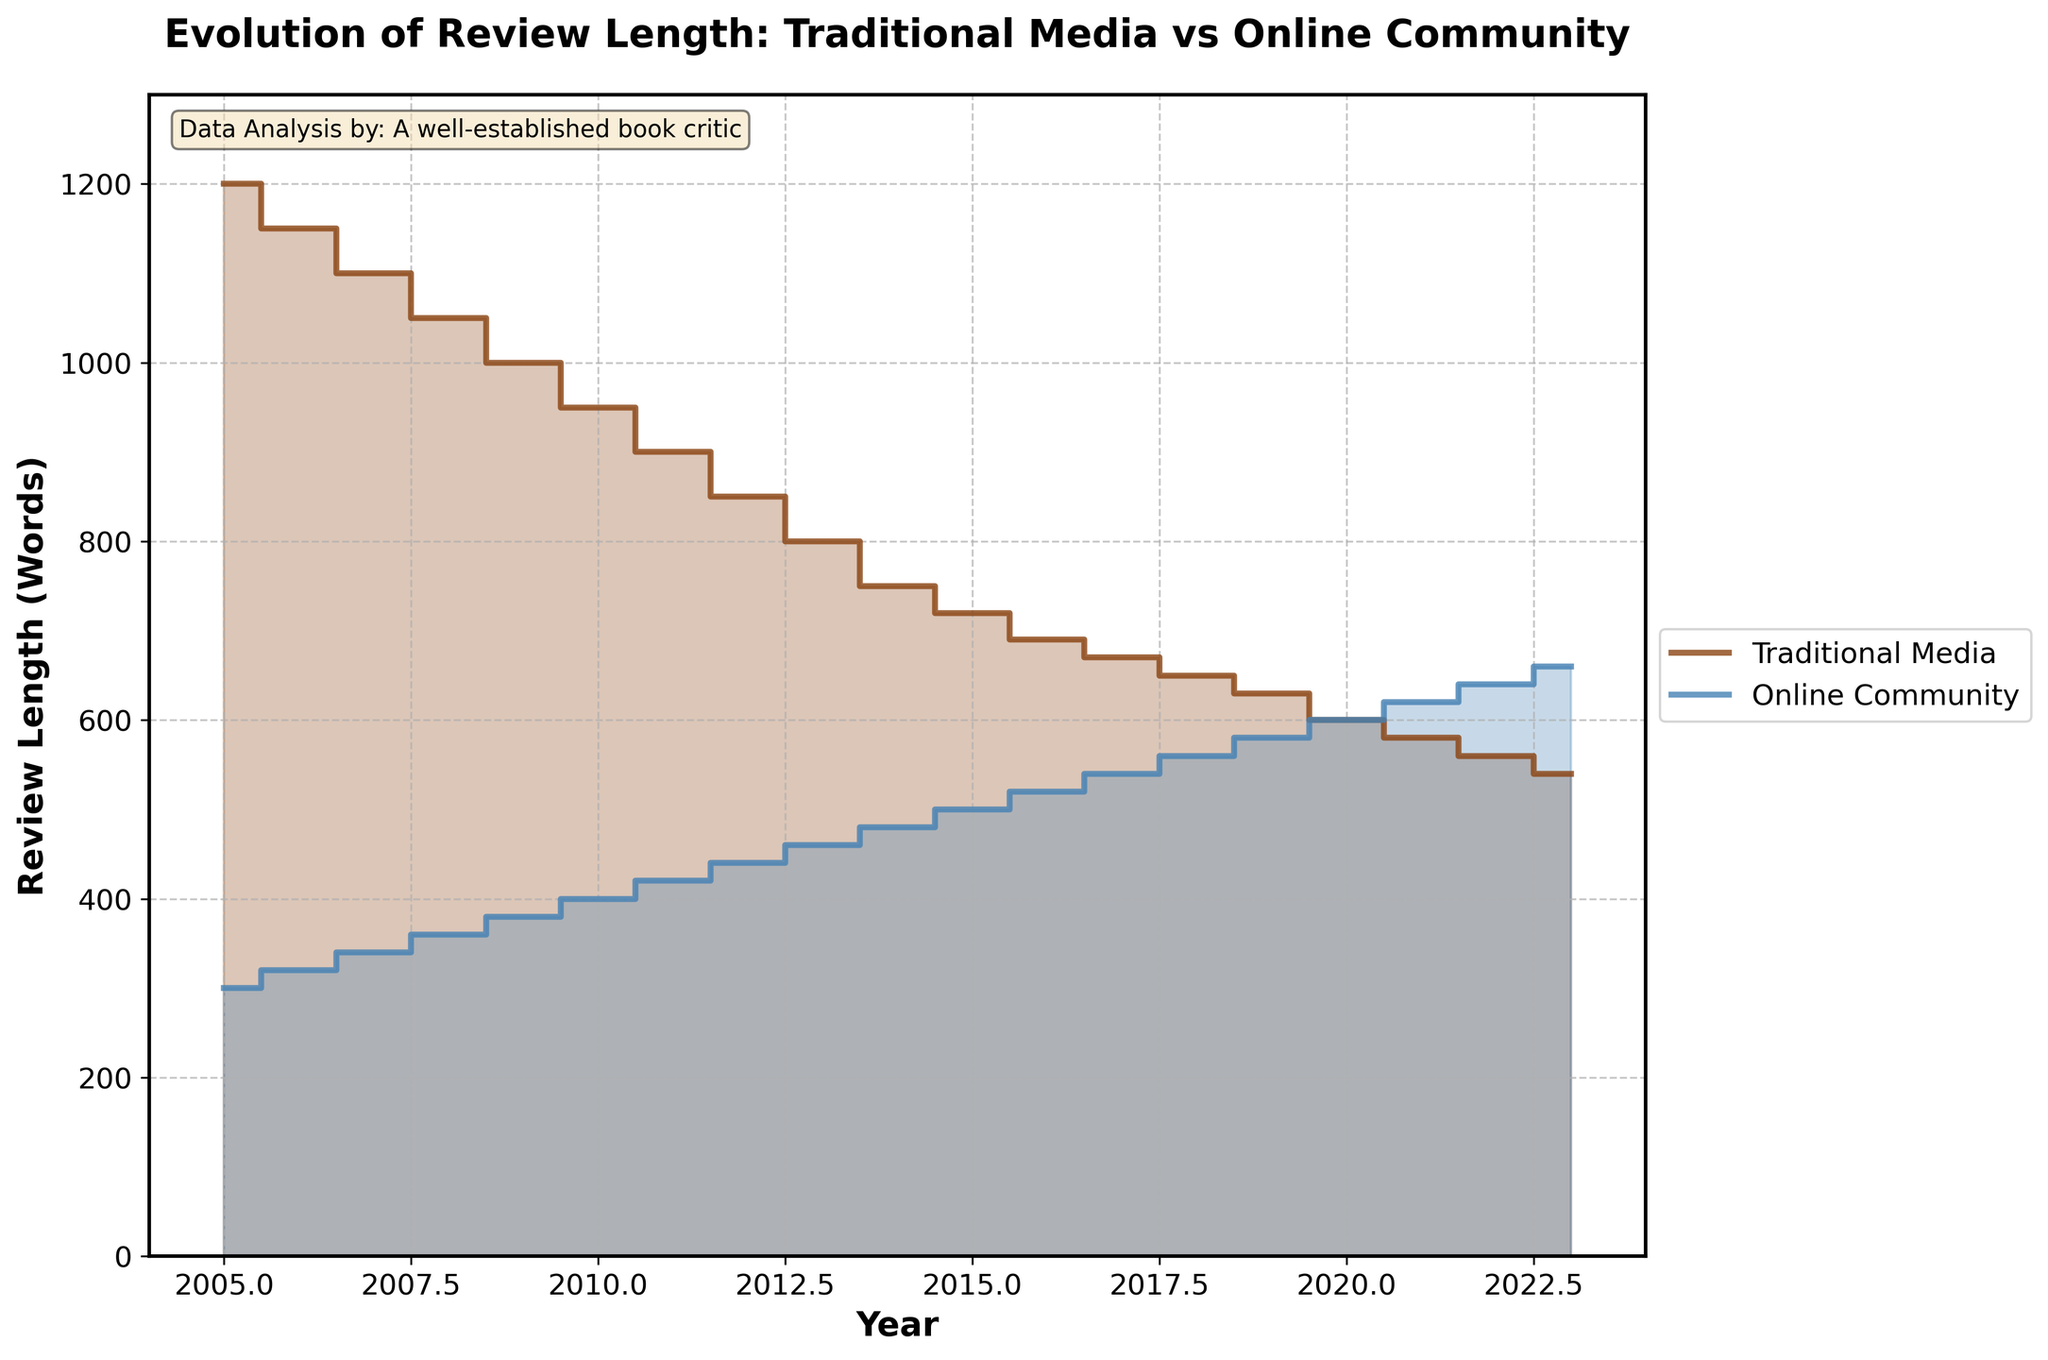What's the title of the figure? The title of the figure can be found at the top of the plot. It states the main subject of the visualization.
Answer: Evolution of Review Length: Traditional Media vs Online Community What are the two platforms compared in the plot? The two platforms compared in the plot are labeled in the legend at the right-hand side of the plot.
Answer: Traditional Media and Online Community What's the trend of review lengths for traditional media from 2005 to 2023? To identify the trend, observe the step plot for Traditional Media from 2005 to 2023. The review lengths gradually decrease over the years.
Answer: Decreasing What's the range of years shown on the x-axis? The x-axis shows the range of years by its tick marks which start from 2005 and end at 2023.
Answer: 2005 to 2023 How many words were reviews in the Online Community in 2010? Find 2010 on the x-axis and follow the step for Online Community (blue line) to determine the review length at that year.
Answer: 400 words Which platform showed an increase in review length over time? By comparing the slopes of the two plots, note that one line increases while the other decreases.
Answer: Online Community What is the difference in review length between the two platforms in 2015? Check the y-values for both Traditional Media and Online Community at the year 2015 and subtract the Online Community value from the Traditional Media value (720 - 500).
Answer: 220 words On which platform were review lengths the longest in 2008? Locate the year 2008 on the x-axis and compare the y-values of the steps for both Traditional Media and Online Community. The highest y-value indicates the longer review lengths.
Answer: Traditional Media How has the review length in Traditional Media changed from 2005 to 2023? Calculate the difference in values from 2005 to 2023 for Traditional Media by subtracting the final value from the initial value (1200 - 540).
Answer: Decreased by 660 words What is the approximate average review length for the Online Community in the latest three years (2021-2023)? Sum the word counts for 2021, 2022, and 2023 in the Online Community (620 + 640 + 660) and divide by 3.
Answer: 640 words 